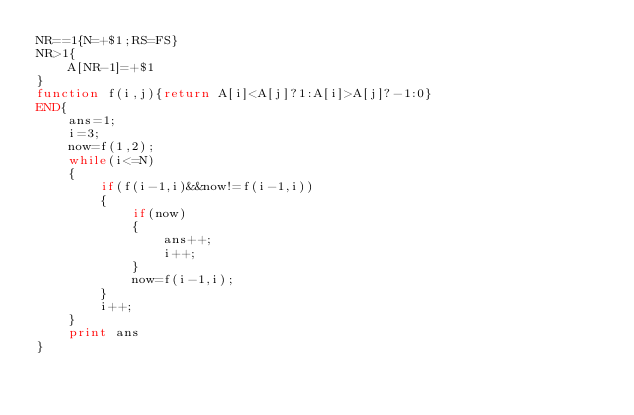<code> <loc_0><loc_0><loc_500><loc_500><_Awk_>NR==1{N=+$1;RS=FS}
NR>1{
	A[NR-1]=+$1
}
function f(i,j){return A[i]<A[j]?1:A[i]>A[j]?-1:0}
END{
	ans=1;
	i=3;
	now=f(1,2);
	while(i<=N)
	{
		if(f(i-1,i)&&now!=f(i-1,i))
		{
			if(now)
			{
				ans++;
				i++;
			}
			now=f(i-1,i);
		}
		i++;
	}
	print ans
}
</code> 